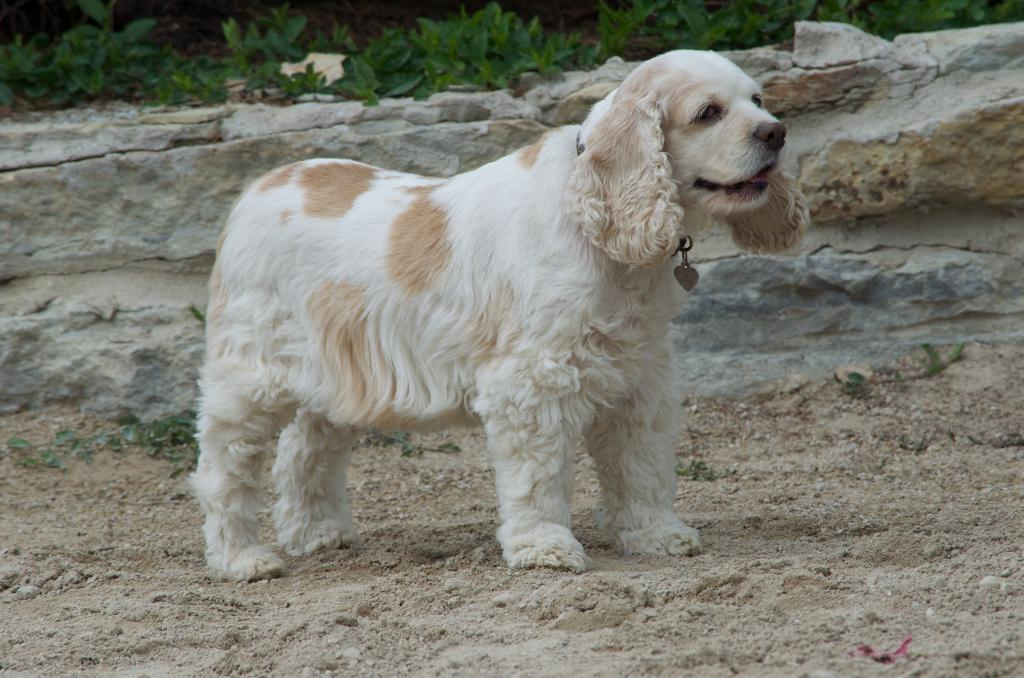What animal can be seen in the image? There is a dog in the image. Where is the dog located? The dog is on the ground. What can be seen in the distance in the image? There is a mountain in the background of the image. What type of vegetation is visible in the background? There are plants in the background of the image. When was the image taken? The image was taken during the day. What type of yam is being knitted with yarn in the image? There is no yam or yarn present in the image; it features a dog on the ground with a mountain and plants in the background. 